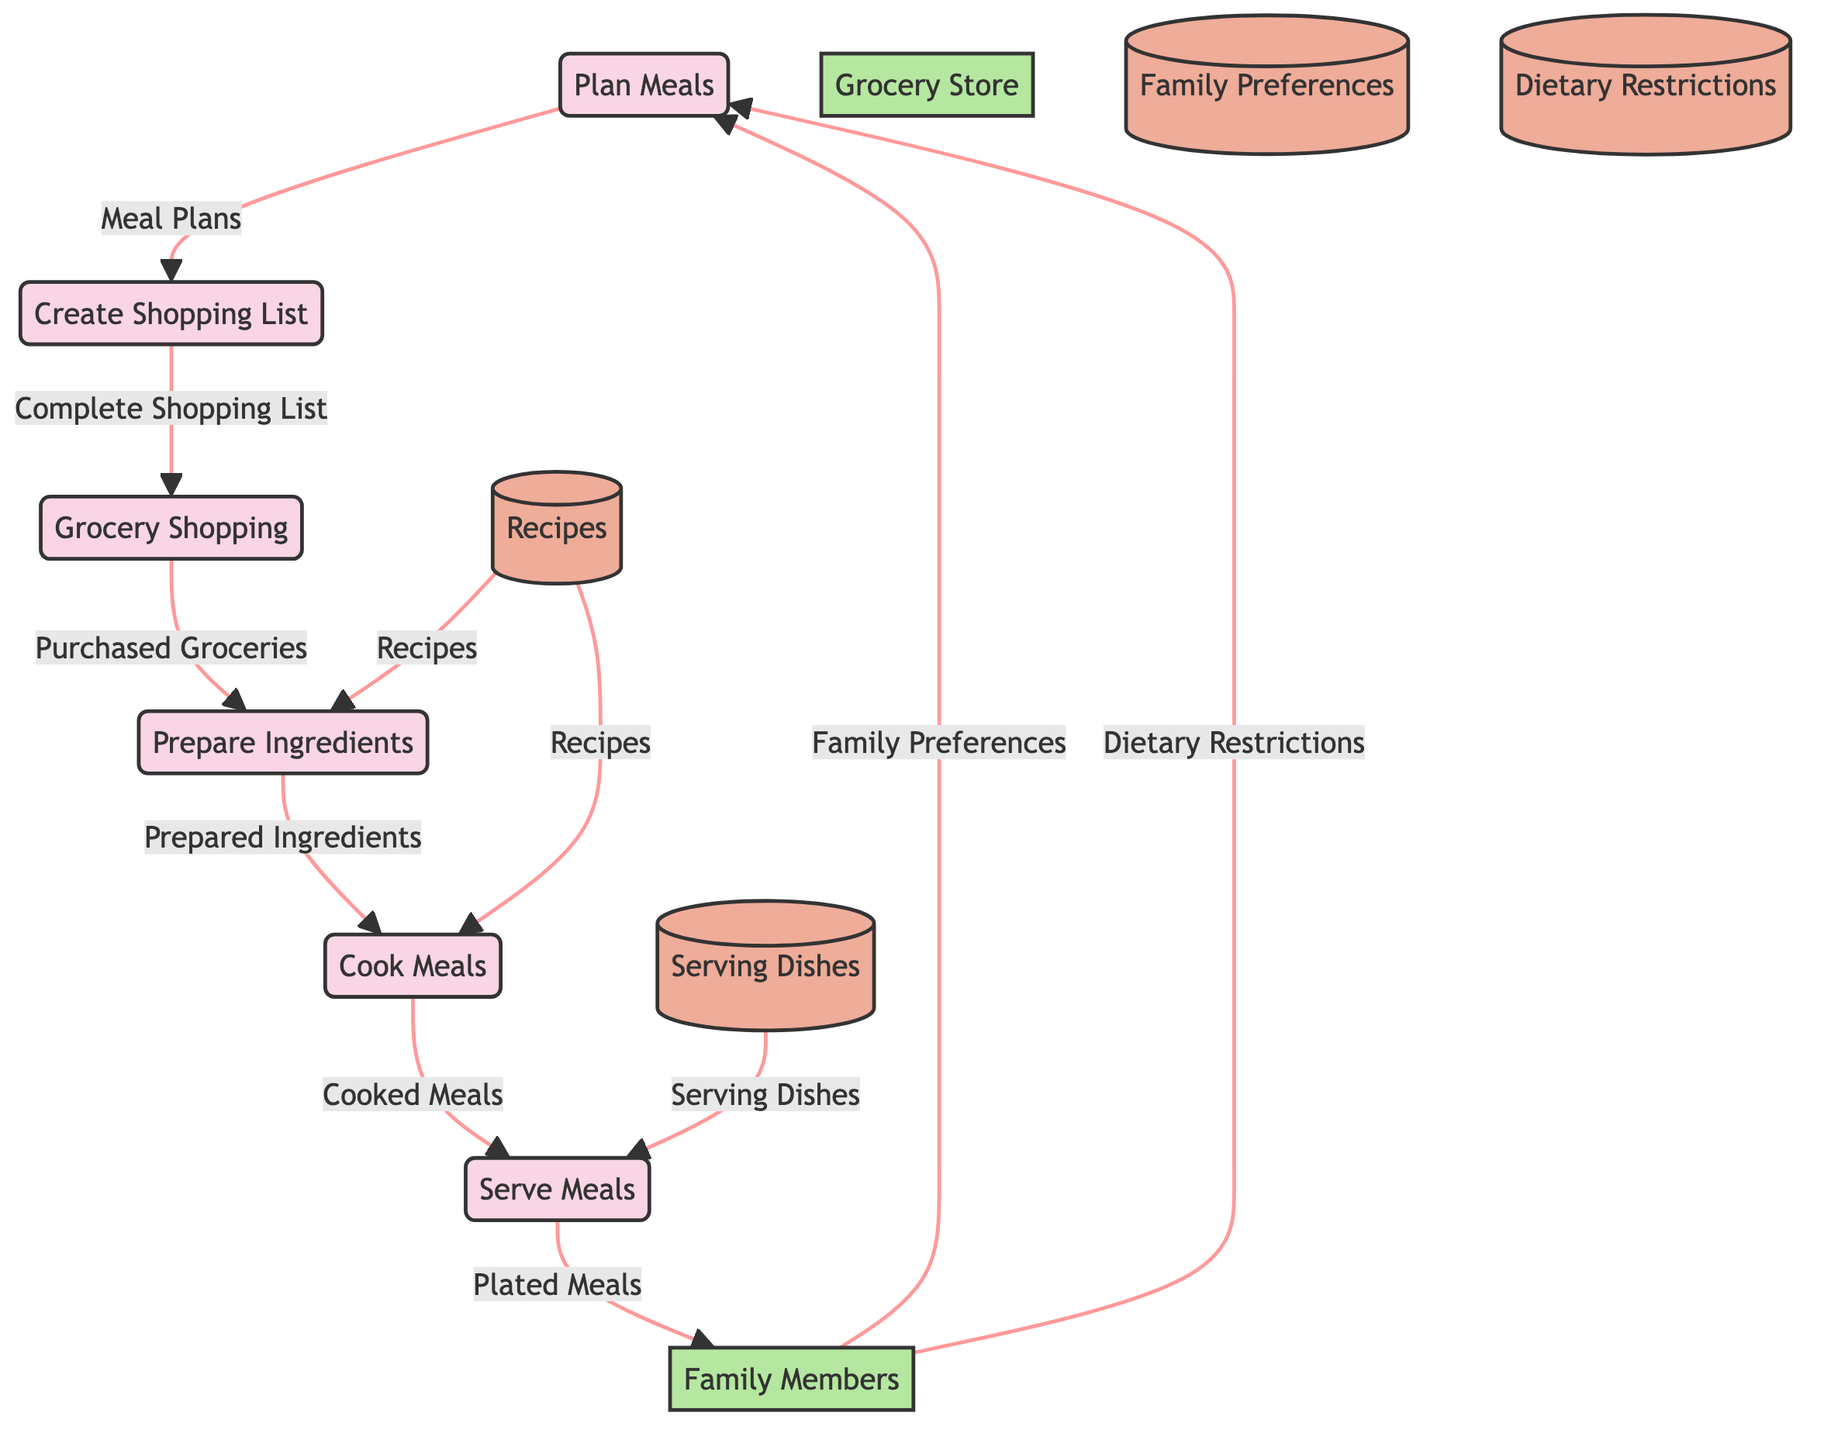What are the inputs to the "Plan Meals" process? The diagram shows that the "Plan Meals" process has two inputs: "Family Preferences" and "Dietary Restrictions". These inputs are coming from the "Family Members" external entity.
Answer: Family Preferences, Dietary Restrictions Which process creates a shopping list? The diagram indicates that the "Create Shopping List" process is responsible for compiling a list of ingredients and items needed for meals. It is the second process in the flow.
Answer: Create Shopping List How many processes are there in this diagram? By counting the nodes labeled as processes in the diagram, we can see there are six distinct processes: Plan Meals, Create Shopping List, Grocery Shopping, Prepare Ingredients, Cook Meals, and Serve Meals.
Answer: Six What is the output of the "Cook Meals" process? According to the diagram, the output of the "Cook Meals" process is "Cooked Meals". This output is produced after this specific process takes the prepared ingredients and recipes as inputs.
Answer: Cooked Meals Which external entity provides inputs to "Plan Meals"? The diagram clearly shows that the "Family Members" external entity provides both the "Family Preferences" and "Dietary Restrictions" inputs to the "Plan Meals" process.
Answer: Family Members What data flows from "Create Shopping List" to "Grocery Shopping"? The diagram shows that the data flowing from "Create Shopping List" to "Grocery Shopping" is the "Complete Shopping List". This flow represents the transition to the next process.
Answer: Complete Shopping List Which data store provides recipes to both "Prepare Ingredients" and "Cook Meals"? The diagram indicates that the "Recipes" data store supplies recipes as an input to both the "Prepare Ingredients" and "Cook Meals" processes, highlighting its importance in meal preparation.
Answer: Recipes How do the "Serving Dishes" interact with the "Serve Meals" process? The diagram illustrates that the "Serving Dishes" data store provides input to the "Serve Meals" process, which indicates the need for serving dishes for the final arrangement of meals.
Answer: Serving Dishes 